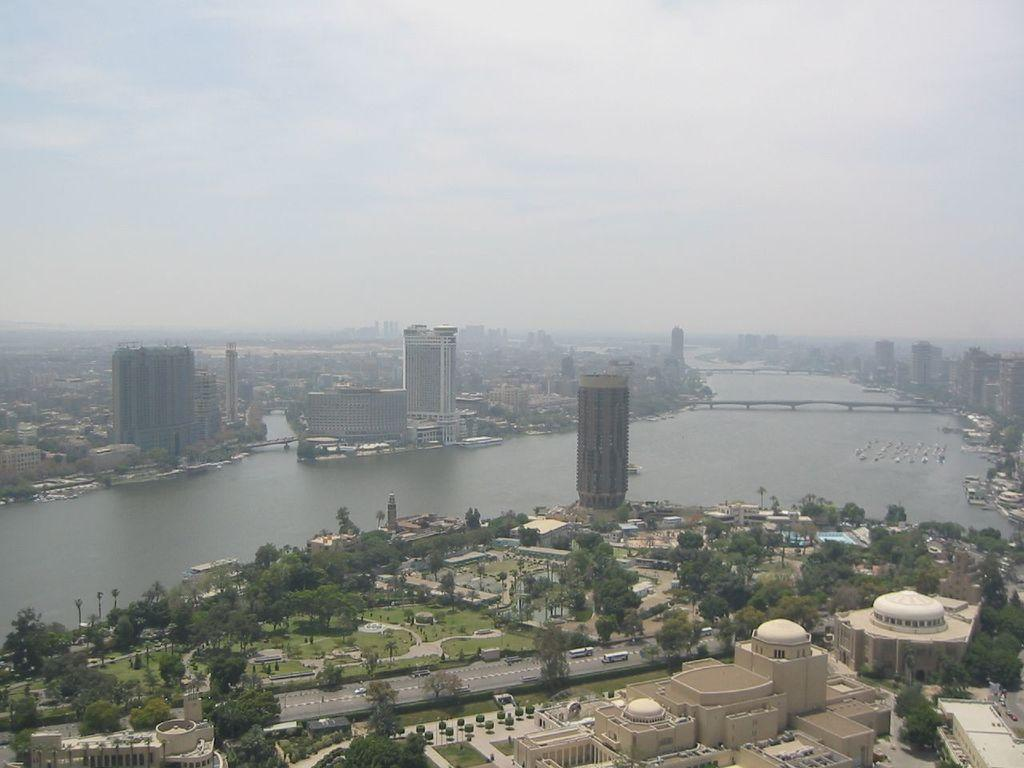What type of structures can be seen in the image? There are buildings in the image. What type of vegetation is present in the image? There are trees and grass in the image. What type of terrain can be seen in the image? There are bridges over the water in the image. What is visible in the sky in the image? There are clouds in the sky in the image. How many dogs are sitting on the cake in the image? There is no cake or dogs present in the image. 